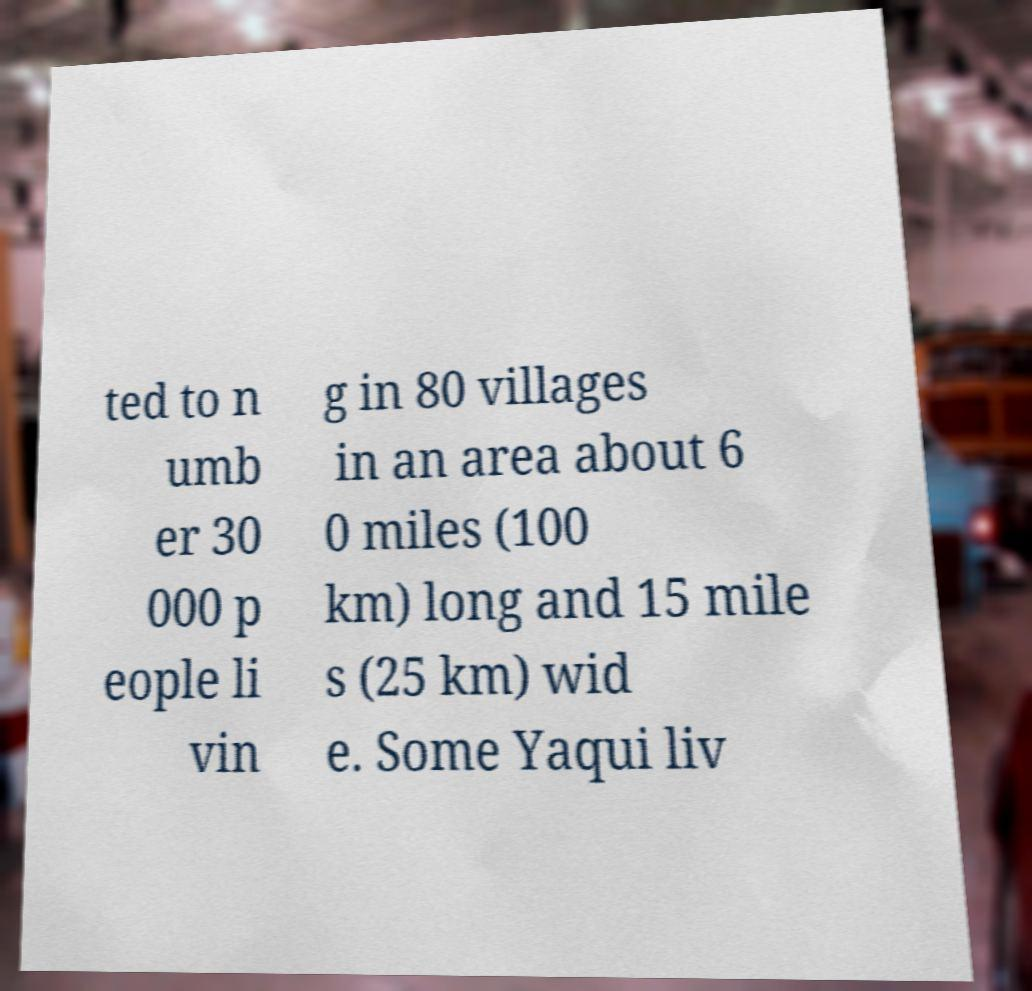For documentation purposes, I need the text within this image transcribed. Could you provide that? ted to n umb er 30 000 p eople li vin g in 80 villages in an area about 6 0 miles (100 km) long and 15 mile s (25 km) wid e. Some Yaqui liv 